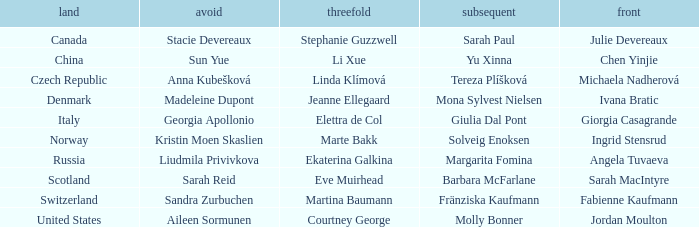What skip has switzerland as the country? Sandra Zurbuchen. 